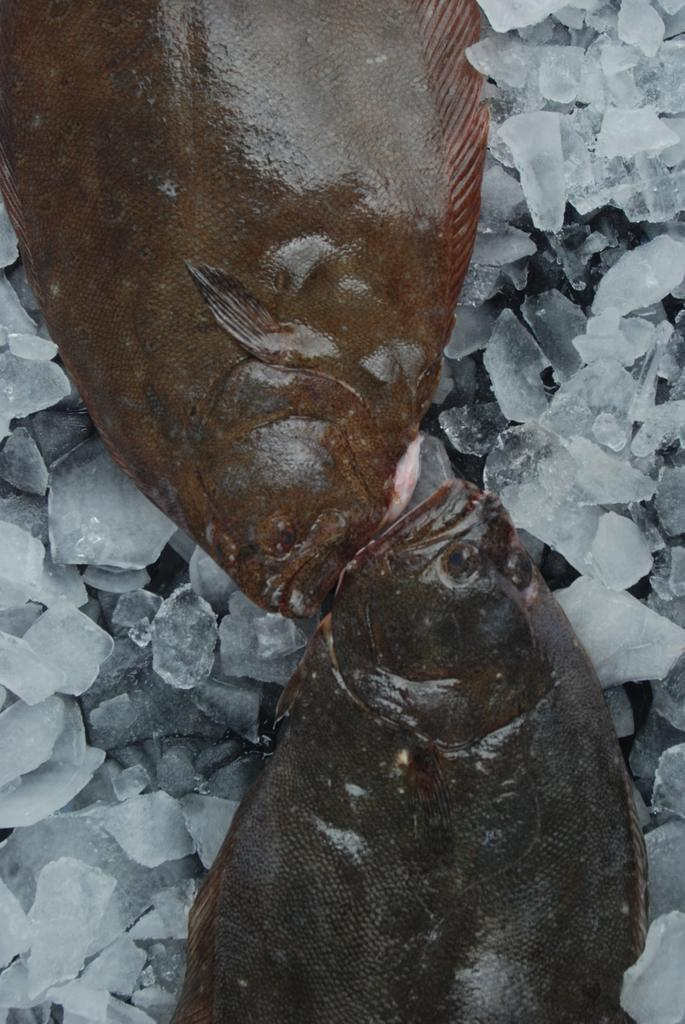What type of animals can be seen in the image? There are fishes in the image. What else is present in the image besides the fishes? There are ice pieces in the image. What color is the front pickle in the image? There is no pickle present in the image, as it only contains fishes and ice pieces. 